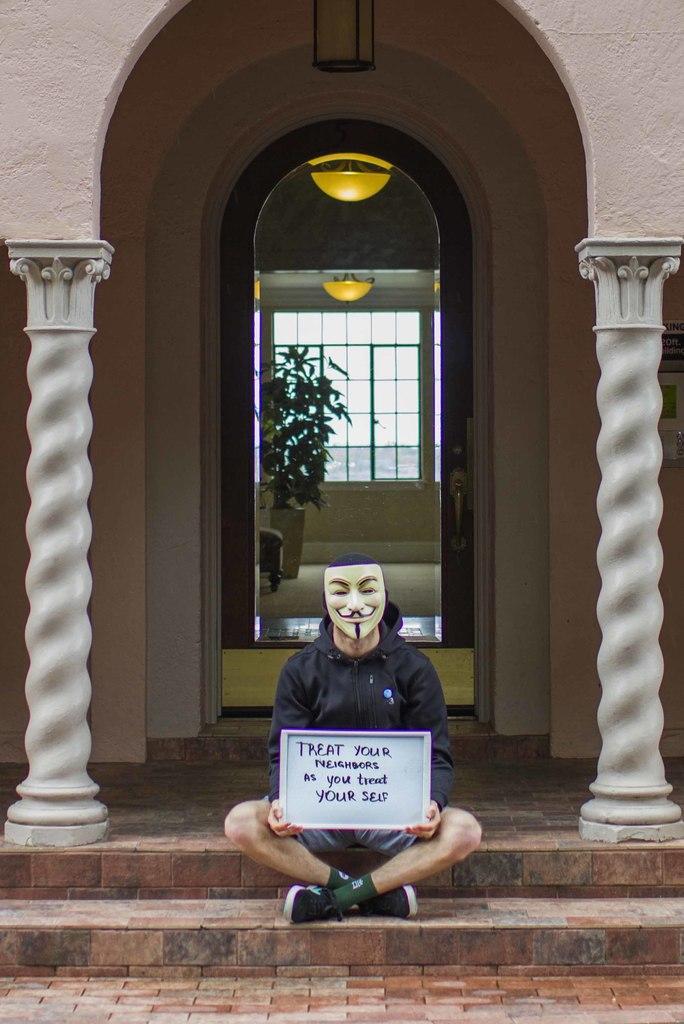Can you describe this image briefly? In the center of the image there is a person wearing a mask and he is holding the pluck card. Behind him there are pillars. There is a door. There are plants, lights. There is a window. In front of the building there are stairs. 